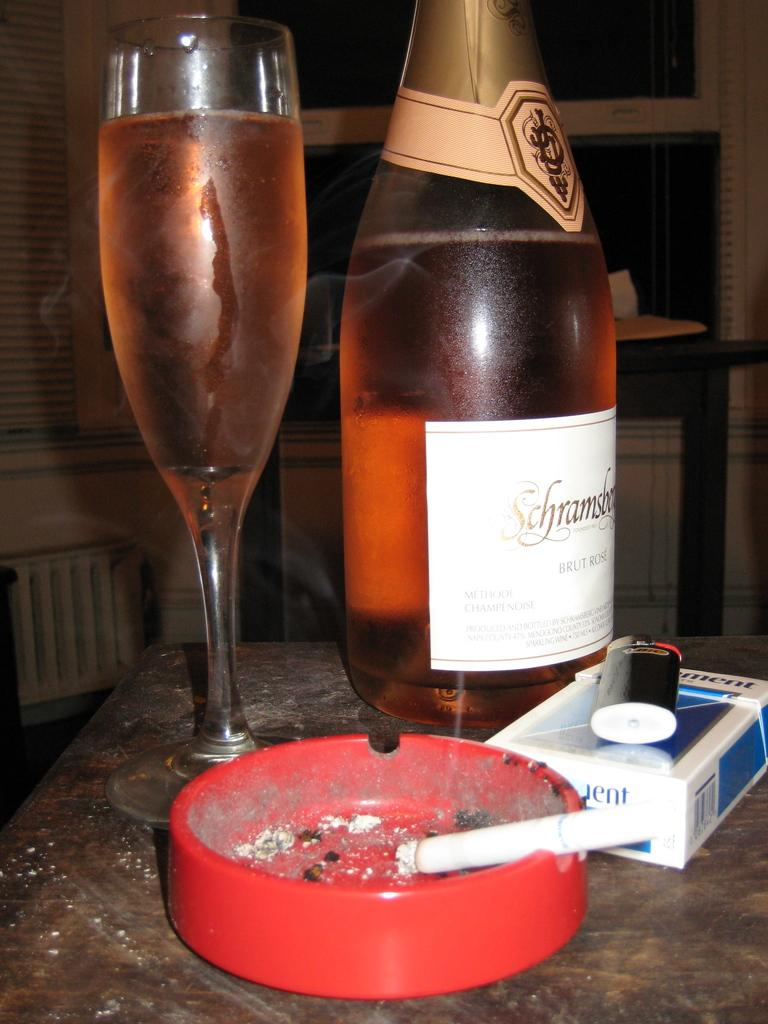What is on the table in the image? There is a glass, a bottle, a cigarette, and a cigarettes box on the table. What is inside the glass and the bottle? The glass and the bottle are both filled with a drink. What might be used to store the cigarettes? There is a cigarettes box on the table, which might be used to store the cigarettes. What is visible in the background of the image? There is a wall in the background. Can you see an ornament hanging from the wall in the image? There is no ornament hanging from the wall in the image; only a wall is visible in the background. Is there anyone running or riding a bike in the image? There are no people or activities involving running or biking depicted in the image. 